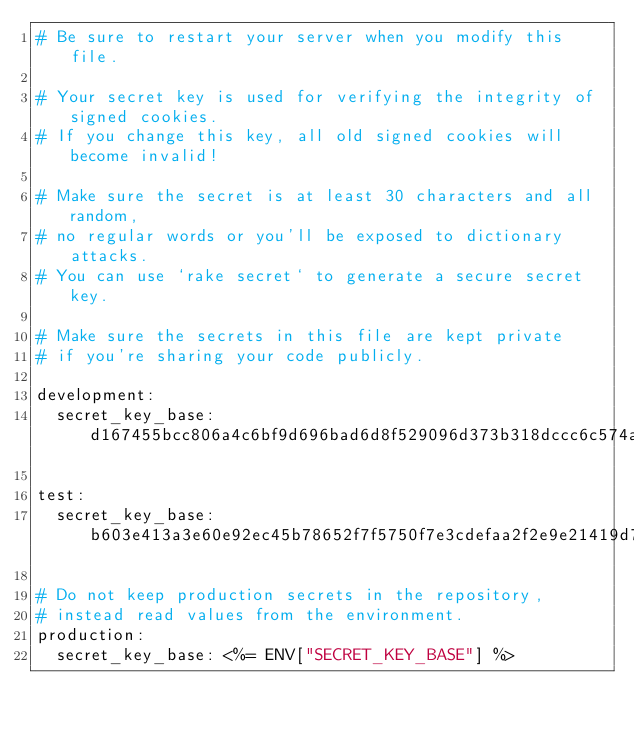<code> <loc_0><loc_0><loc_500><loc_500><_YAML_># Be sure to restart your server when you modify this file.

# Your secret key is used for verifying the integrity of signed cookies.
# If you change this key, all old signed cookies will become invalid!

# Make sure the secret is at least 30 characters and all random,
# no regular words or you'll be exposed to dictionary attacks.
# You can use `rake secret` to generate a secure secret key.

# Make sure the secrets in this file are kept private
# if you're sharing your code publicly.

development:
  secret_key_base: d167455bcc806a4c6bf9d696bad6d8f529096d373b318dccc6c574a39617d1339ccca0db975697e6dcae36a77ba623200ed146c2cae4e4979d9501f48fba1c67

test:
  secret_key_base: b603e413a3e60e92ec45b78652f7f5750f7e3cdefaa2f2e9e21419d7306b48d1f0e3b577155d58e4604d6805a07e47d9c48aea30d727fd24e10e23df10e4b2e6

# Do not keep production secrets in the repository,
# instead read values from the environment.
production:
  secret_key_base: <%= ENV["SECRET_KEY_BASE"] %>
</code> 